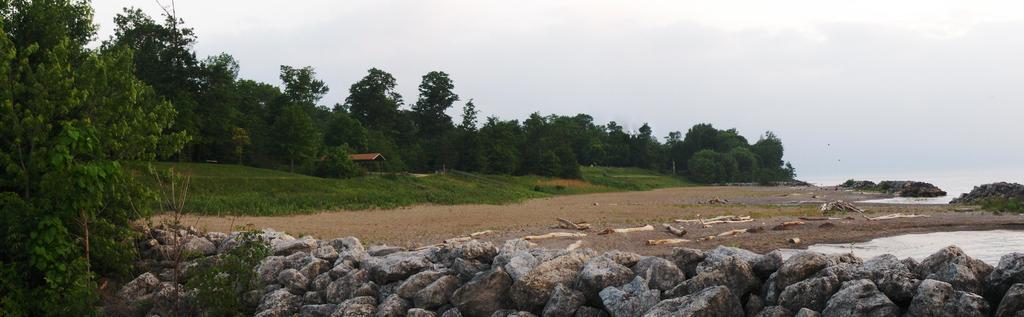Please provide a concise description of this image. In this image there are trees. On the right there is water. At the bottom we can see stones. In the background there is sky. We can see a shed. 